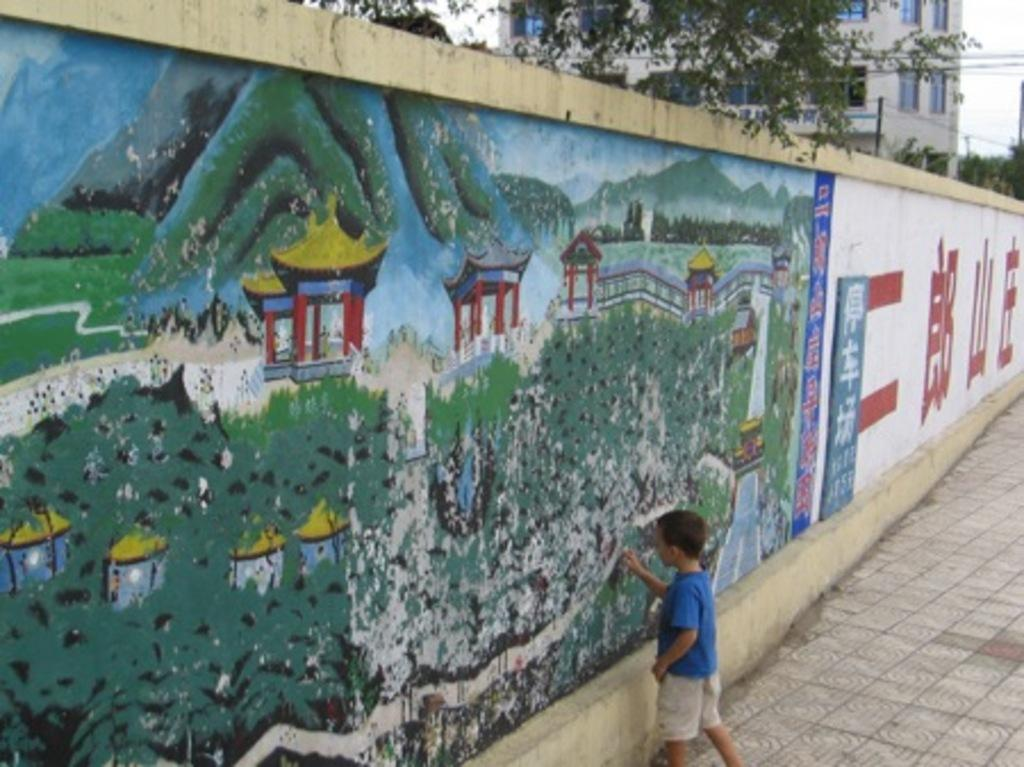What can be seen in the background of the image? There is a building, trees, and the sky visible in the background of the image. What is the primary feature of the image? The primary feature of the image is a boy. What is the boy wearing in the image? The boy is wearing a blue t-shirt in the image. Where is the boy located in the image? The boy is standing near the wall in the image. What type of government is depicted in the image? There is no depiction of a government in the image; it features include a boy, a wall, and a background with a building, trees, and sky. Can you see a lake in the image? There is no lake present in the image. 